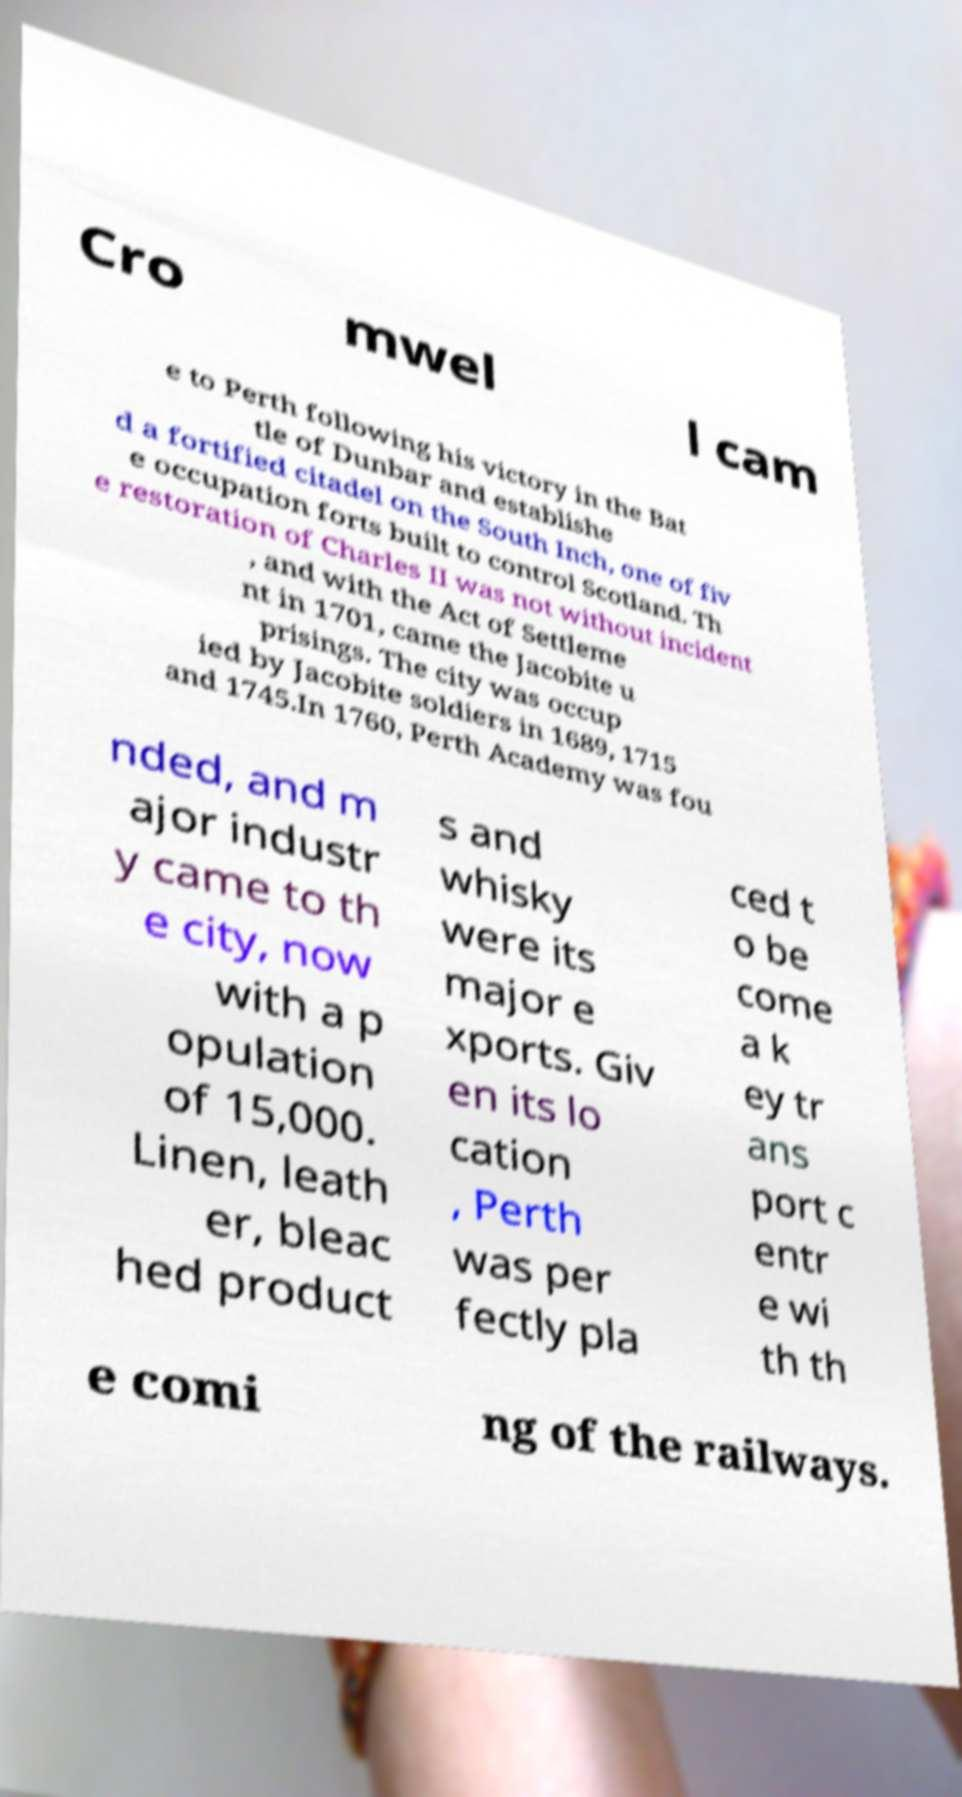There's text embedded in this image that I need extracted. Can you transcribe it verbatim? Cro mwel l cam e to Perth following his victory in the Bat tle of Dunbar and establishe d a fortified citadel on the South Inch, one of fiv e occupation forts built to control Scotland. Th e restoration of Charles II was not without incident , and with the Act of Settleme nt in 1701, came the Jacobite u prisings. The city was occup ied by Jacobite soldiers in 1689, 1715 and 1745.In 1760, Perth Academy was fou nded, and m ajor industr y came to th e city, now with a p opulation of 15,000. Linen, leath er, bleac hed product s and whisky were its major e xports. Giv en its lo cation , Perth was per fectly pla ced t o be come a k ey tr ans port c entr e wi th th e comi ng of the railways. 